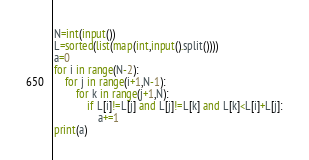<code> <loc_0><loc_0><loc_500><loc_500><_Python_>N=int(input())
L=sorted(list(map(int,input().split())))
a=0
for i in range(N-2):
    for j in range(i+1,N-1):
        for k in range(j+1,N):
            if L[i]!=L[j] and L[j]!=L[k] and L[k]<L[i]+L[j]:
                a+=1
print(a)</code> 